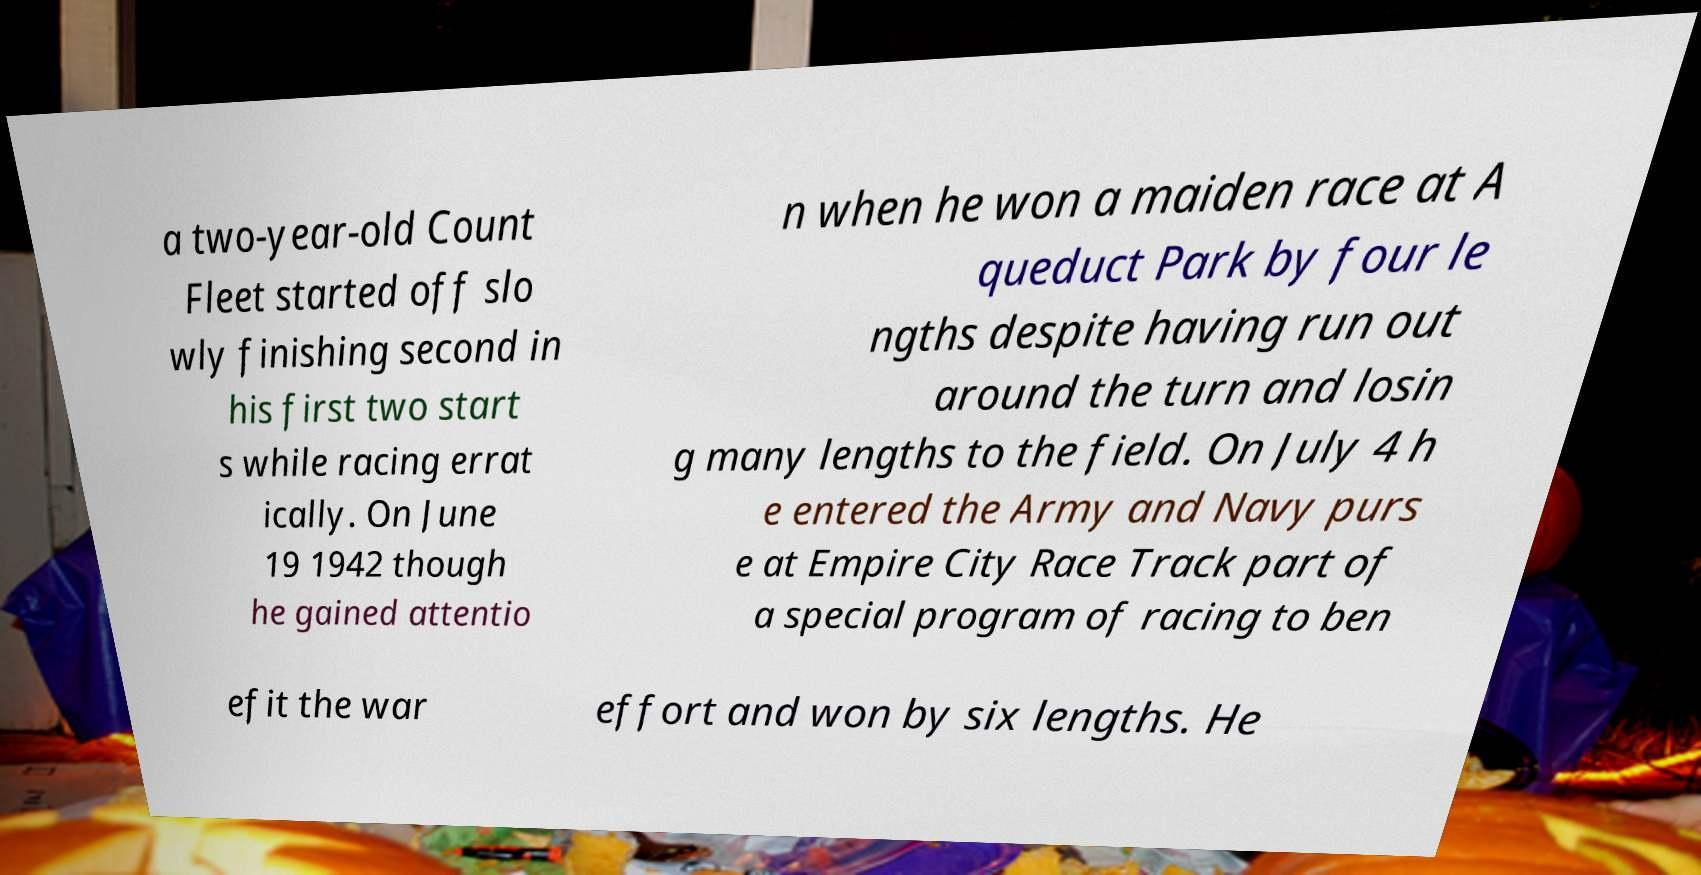Could you extract and type out the text from this image? a two-year-old Count Fleet started off slo wly finishing second in his first two start s while racing errat ically. On June 19 1942 though he gained attentio n when he won a maiden race at A queduct Park by four le ngths despite having run out around the turn and losin g many lengths to the field. On July 4 h e entered the Army and Navy purs e at Empire City Race Track part of a special program of racing to ben efit the war effort and won by six lengths. He 